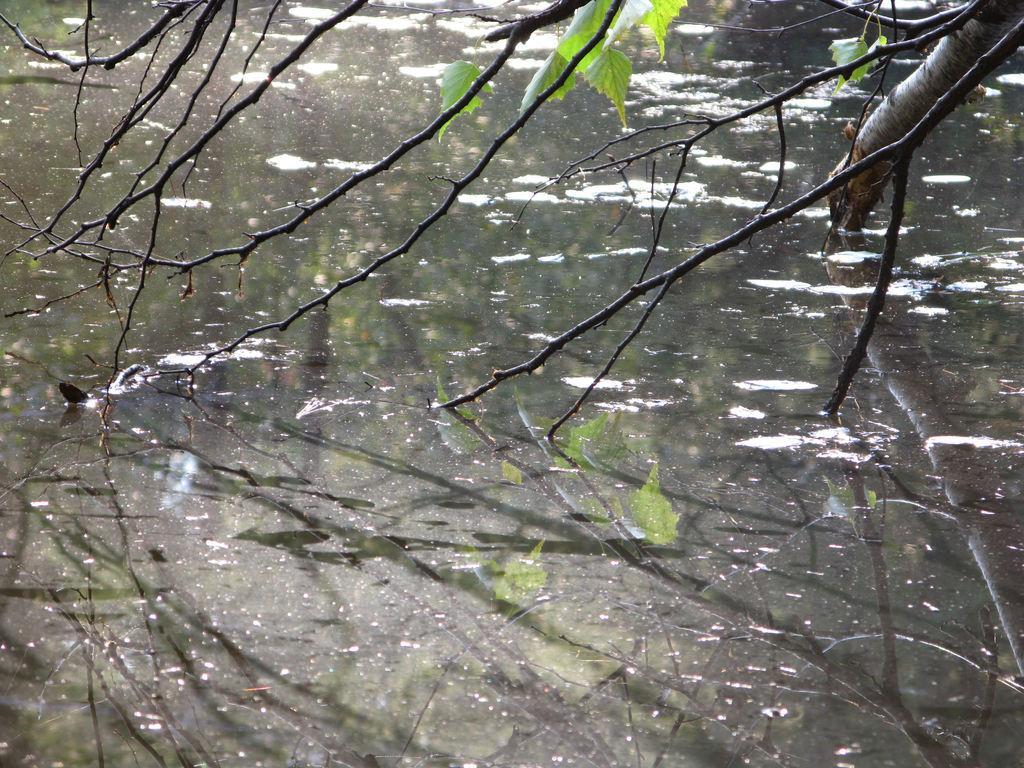How would you summarize this image in a sentence or two? There is a water surface and there is a tree above the water surface. It is mostly dry. 